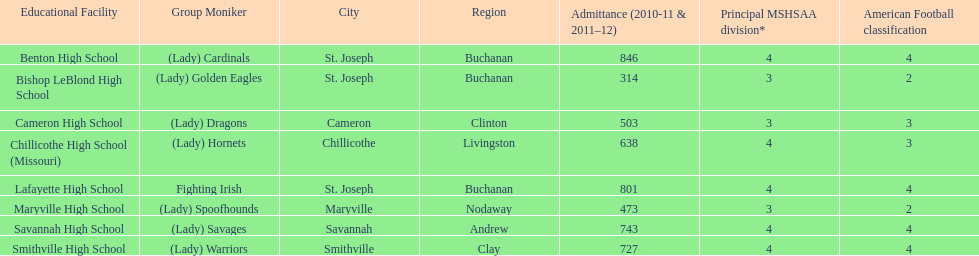How many schools are there in this conference? 8. 